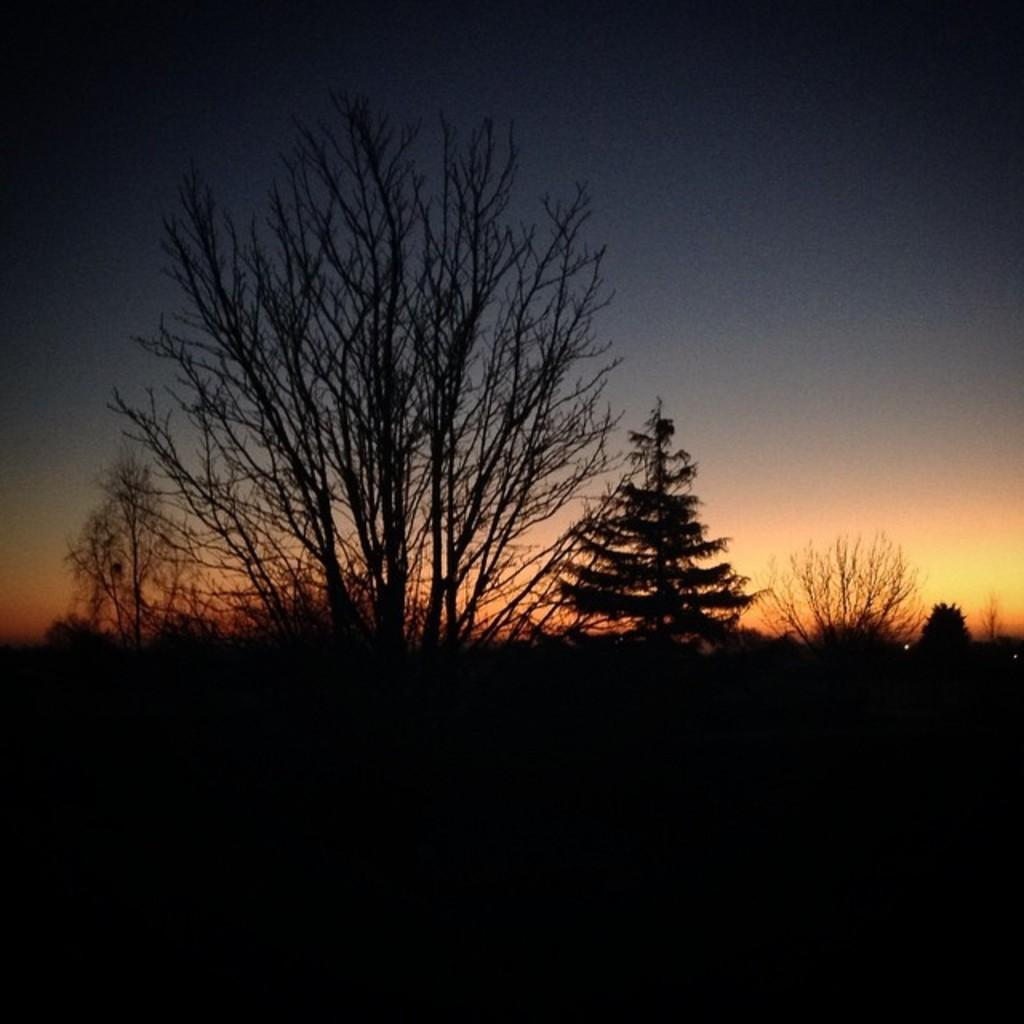What is located in the foreground of the image? There are trees in the foreground of the image. What can be seen in the background of the image? The sky is visible in the background of the image. What might be suggested by the appearance of the sky in the image? The image appears to depict a sunset. What thing is sneezing in the image? There is no thing sneezing in the image, as it does not depict any living beings or objects capable of sneezing. What type of cast is visible in the image? There is no cast present in the image. 